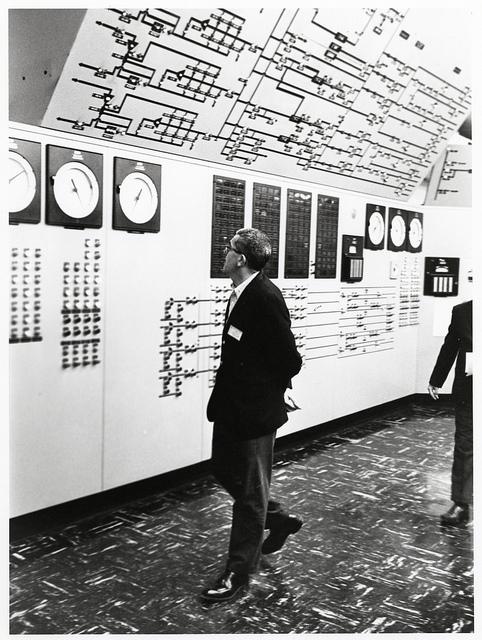How many colors are in this photo?
Give a very brief answer. 2. Is this an experimental laboratory?
Quick response, please. Yes. What is the person in this picture looking at?
Quick response, please. Clock. 